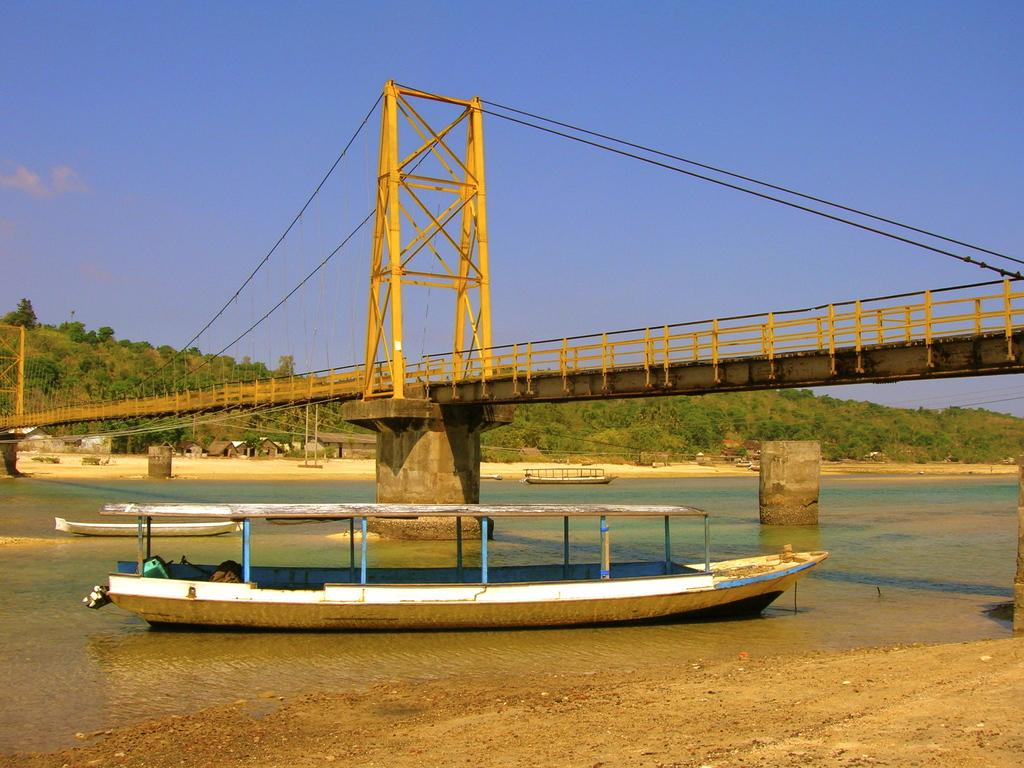What is the main subject of the image? There is a boat in the image. Where is the boat located? The boat is on a river. What can be seen in the background of the image? There is a bridge across the river and trees visible in the background. What is the color of the sky in the image? The sky is blue in the image. Can you see your friend waving from the boat in the image? There is no friend visible in the image, and no one is waving. Is the boat on a lake or a river in the image? The boat is on a river in the image, not a lake. 